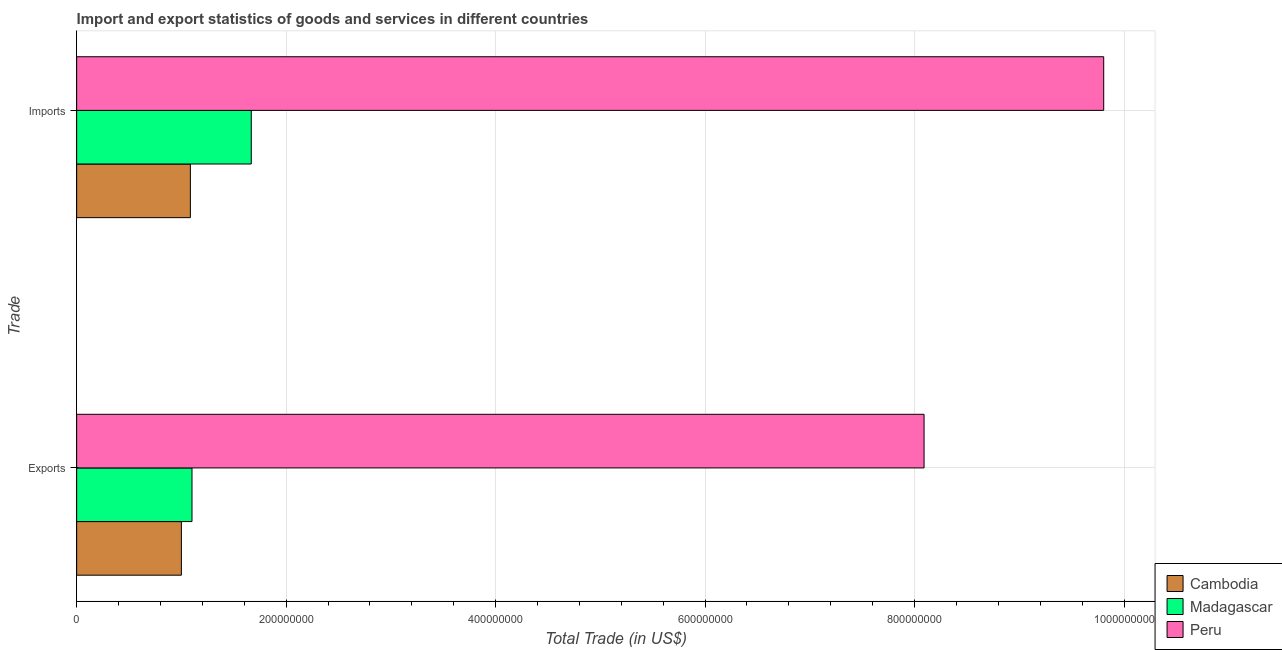Are the number of bars per tick equal to the number of legend labels?
Ensure brevity in your answer.  Yes. How many bars are there on the 1st tick from the bottom?
Keep it short and to the point. 3. What is the label of the 2nd group of bars from the top?
Offer a terse response. Exports. What is the export of goods and services in Madagascar?
Make the answer very short. 1.10e+08. Across all countries, what is the maximum imports of goods and services?
Make the answer very short. 9.81e+08. Across all countries, what is the minimum imports of goods and services?
Your response must be concise. 1.09e+08. In which country was the export of goods and services maximum?
Make the answer very short. Peru. In which country was the export of goods and services minimum?
Keep it short and to the point. Cambodia. What is the total imports of goods and services in the graph?
Ensure brevity in your answer.  1.26e+09. What is the difference between the export of goods and services in Peru and that in Cambodia?
Offer a terse response. 7.09e+08. What is the difference between the export of goods and services in Peru and the imports of goods and services in Madagascar?
Your response must be concise. 6.42e+08. What is the average imports of goods and services per country?
Keep it short and to the point. 4.19e+08. What is the difference between the imports of goods and services and export of goods and services in Cambodia?
Your answer should be very brief. 8.57e+06. In how many countries, is the export of goods and services greater than 920000000 US$?
Make the answer very short. 0. What is the ratio of the imports of goods and services in Peru to that in Madagascar?
Offer a terse response. 5.88. What does the 2nd bar from the top in Exports represents?
Make the answer very short. Madagascar. What does the 2nd bar from the bottom in Imports represents?
Offer a very short reply. Madagascar. What is the difference between two consecutive major ticks on the X-axis?
Provide a short and direct response. 2.00e+08. Are the values on the major ticks of X-axis written in scientific E-notation?
Offer a terse response. No. Where does the legend appear in the graph?
Your answer should be very brief. Bottom right. What is the title of the graph?
Provide a short and direct response. Import and export statistics of goods and services in different countries. Does "Ecuador" appear as one of the legend labels in the graph?
Make the answer very short. No. What is the label or title of the X-axis?
Provide a short and direct response. Total Trade (in US$). What is the label or title of the Y-axis?
Give a very brief answer. Trade. What is the Total Trade (in US$) in Madagascar in Exports?
Offer a very short reply. 1.10e+08. What is the Total Trade (in US$) of Peru in Exports?
Provide a succinct answer. 8.09e+08. What is the Total Trade (in US$) in Cambodia in Imports?
Your answer should be very brief. 1.09e+08. What is the Total Trade (in US$) in Madagascar in Imports?
Ensure brevity in your answer.  1.67e+08. What is the Total Trade (in US$) in Peru in Imports?
Your answer should be very brief. 9.81e+08. Across all Trade, what is the maximum Total Trade (in US$) in Cambodia?
Your answer should be compact. 1.09e+08. Across all Trade, what is the maximum Total Trade (in US$) in Madagascar?
Give a very brief answer. 1.67e+08. Across all Trade, what is the maximum Total Trade (in US$) in Peru?
Make the answer very short. 9.81e+08. Across all Trade, what is the minimum Total Trade (in US$) in Cambodia?
Offer a terse response. 1.00e+08. Across all Trade, what is the minimum Total Trade (in US$) in Madagascar?
Your answer should be compact. 1.10e+08. Across all Trade, what is the minimum Total Trade (in US$) of Peru?
Offer a terse response. 8.09e+08. What is the total Total Trade (in US$) in Cambodia in the graph?
Offer a terse response. 2.09e+08. What is the total Total Trade (in US$) of Madagascar in the graph?
Keep it short and to the point. 2.77e+08. What is the total Total Trade (in US$) of Peru in the graph?
Your response must be concise. 1.79e+09. What is the difference between the Total Trade (in US$) in Cambodia in Exports and that in Imports?
Provide a succinct answer. -8.57e+06. What is the difference between the Total Trade (in US$) of Madagascar in Exports and that in Imports?
Your response must be concise. -5.66e+07. What is the difference between the Total Trade (in US$) of Peru in Exports and that in Imports?
Offer a terse response. -1.72e+08. What is the difference between the Total Trade (in US$) in Cambodia in Exports and the Total Trade (in US$) in Madagascar in Imports?
Give a very brief answer. -6.67e+07. What is the difference between the Total Trade (in US$) of Cambodia in Exports and the Total Trade (in US$) of Peru in Imports?
Provide a succinct answer. -8.81e+08. What is the difference between the Total Trade (in US$) in Madagascar in Exports and the Total Trade (in US$) in Peru in Imports?
Offer a terse response. -8.70e+08. What is the average Total Trade (in US$) in Cambodia per Trade?
Provide a short and direct response. 1.04e+08. What is the average Total Trade (in US$) in Madagascar per Trade?
Ensure brevity in your answer.  1.38e+08. What is the average Total Trade (in US$) of Peru per Trade?
Offer a very short reply. 8.95e+08. What is the difference between the Total Trade (in US$) of Cambodia and Total Trade (in US$) of Madagascar in Exports?
Make the answer very short. -1.01e+07. What is the difference between the Total Trade (in US$) of Cambodia and Total Trade (in US$) of Peru in Exports?
Offer a terse response. -7.09e+08. What is the difference between the Total Trade (in US$) of Madagascar and Total Trade (in US$) of Peru in Exports?
Give a very brief answer. -6.99e+08. What is the difference between the Total Trade (in US$) in Cambodia and Total Trade (in US$) in Madagascar in Imports?
Your response must be concise. -5.81e+07. What is the difference between the Total Trade (in US$) in Cambodia and Total Trade (in US$) in Peru in Imports?
Your answer should be very brief. -8.72e+08. What is the difference between the Total Trade (in US$) of Madagascar and Total Trade (in US$) of Peru in Imports?
Your answer should be very brief. -8.14e+08. What is the ratio of the Total Trade (in US$) of Cambodia in Exports to that in Imports?
Offer a terse response. 0.92. What is the ratio of the Total Trade (in US$) of Madagascar in Exports to that in Imports?
Your answer should be compact. 0.66. What is the ratio of the Total Trade (in US$) in Peru in Exports to that in Imports?
Your answer should be very brief. 0.83. What is the difference between the highest and the second highest Total Trade (in US$) of Cambodia?
Your answer should be compact. 8.57e+06. What is the difference between the highest and the second highest Total Trade (in US$) of Madagascar?
Give a very brief answer. 5.66e+07. What is the difference between the highest and the second highest Total Trade (in US$) of Peru?
Your answer should be compact. 1.72e+08. What is the difference between the highest and the lowest Total Trade (in US$) of Cambodia?
Offer a very short reply. 8.57e+06. What is the difference between the highest and the lowest Total Trade (in US$) of Madagascar?
Your answer should be compact. 5.66e+07. What is the difference between the highest and the lowest Total Trade (in US$) of Peru?
Your answer should be compact. 1.72e+08. 